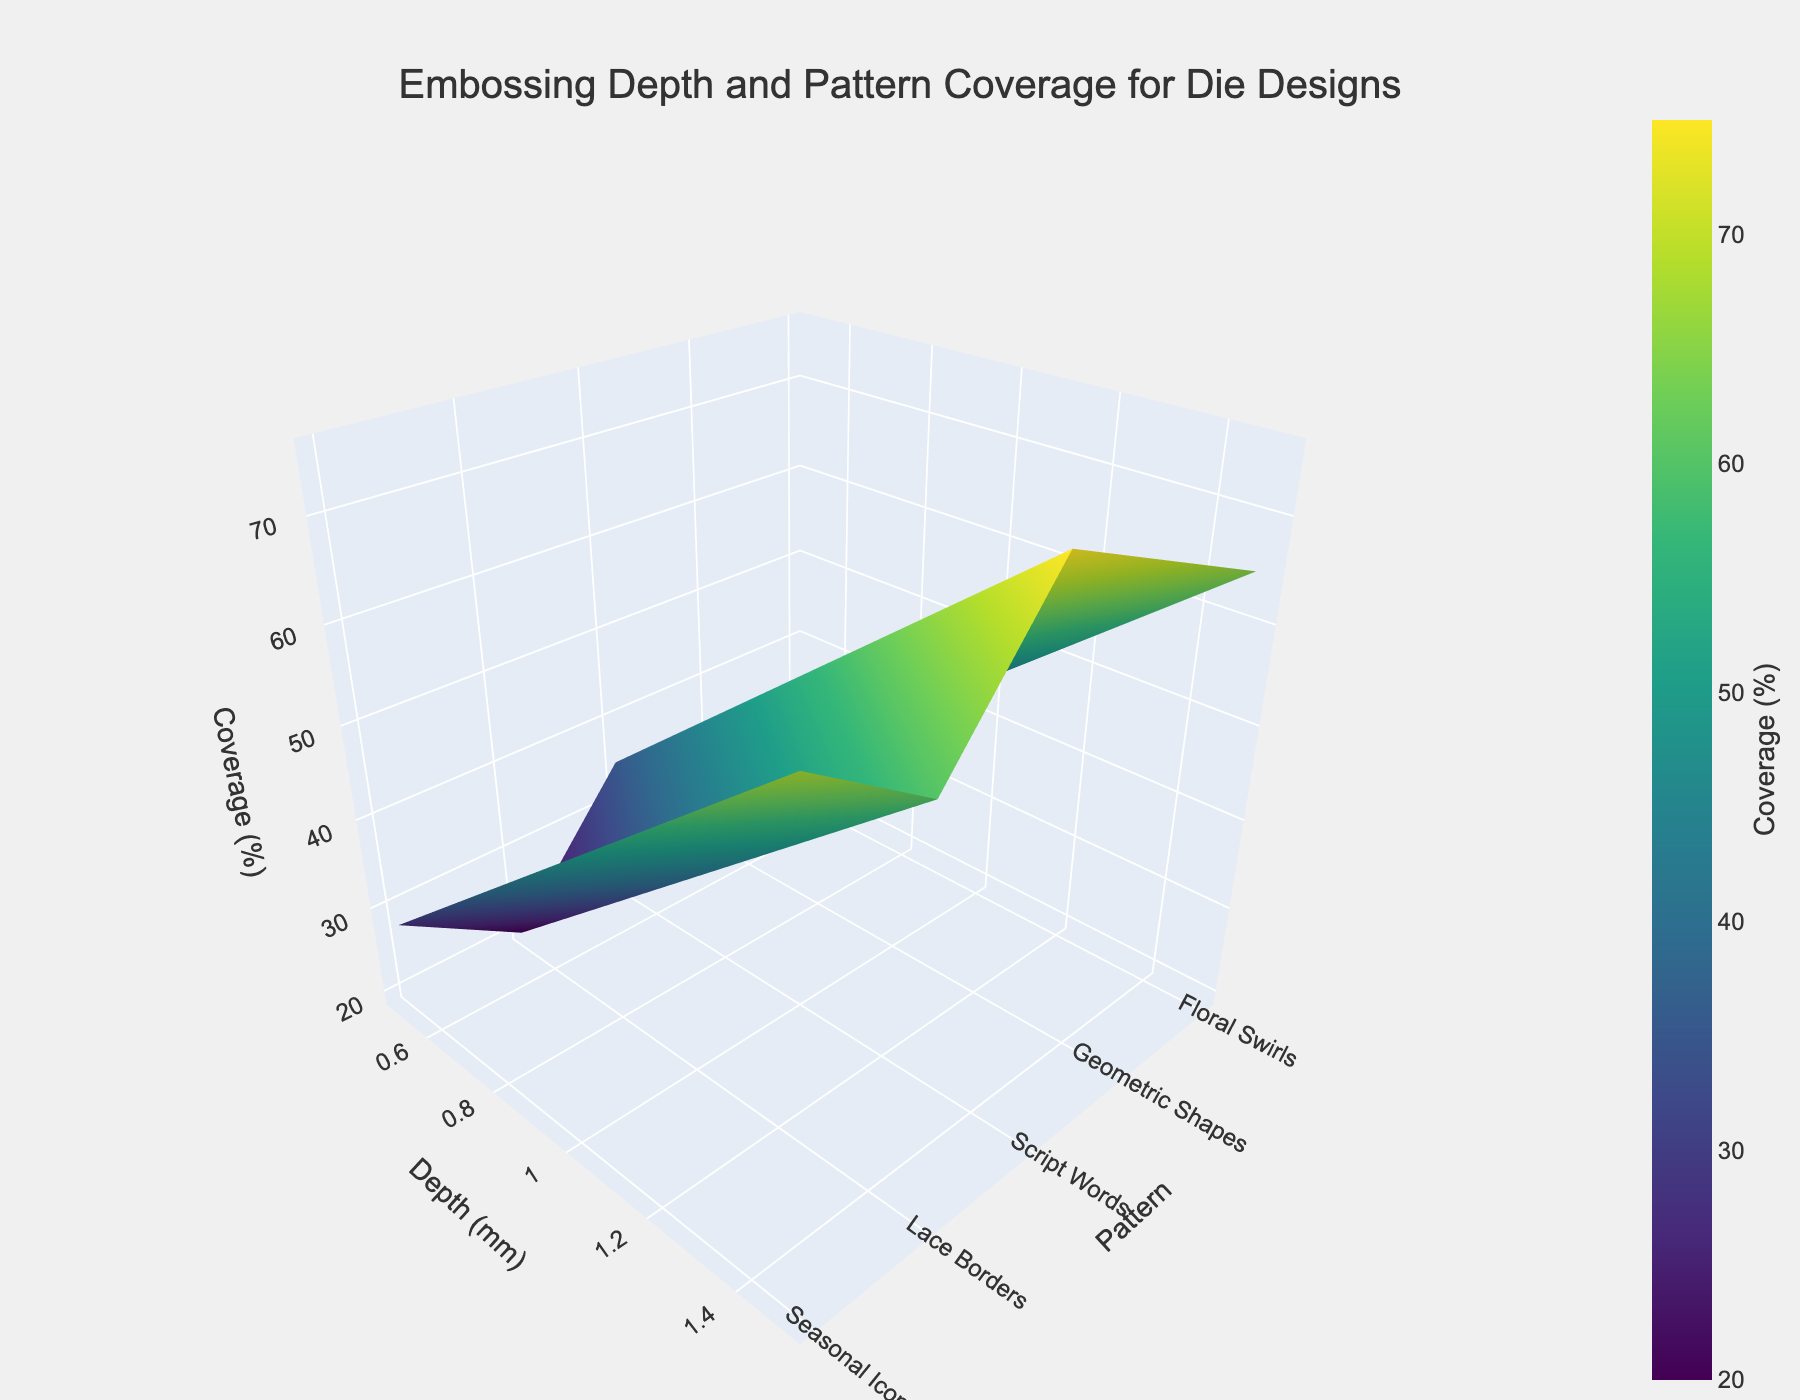What is the title of the figure? The title of the figure can be found at the top center of the plot. It serves to briefly describe the content or purpose of the figure. The title of this specific figure reads "Embossing Depth and Pattern Coverage for Die Designs".
Answer: Embossing Depth and Pattern Coverage for Die Designs Which pattern has the lowest coverage at a depth of 0.5 mm? To find the pattern with the lowest coverage at a depth of 0.5 mm, look at the z-axis values corresponding to 0.5 mm on the y-axis. The pattern with the minimum value will be the answer. The smallest coverage at 0.5 mm depth belongs to "Script Words".
Answer: Script Words How does the coverage percentage change for "Geometric Shapes" as the depth increases from 0.5 mm to 1.5 mm? To observe the change, look at the z-axis values for "Geometric Shapes" at depths 0.5 mm, 1.0 mm, and 1.5 mm. The coverage increases as follows: 30% at 0.5 mm, 50% at 1.0 mm, and 70% at 1.5 mm.
Answer: It increases from 30% to 70% Which pattern shows the steepest increase in coverage percentage from 0.5 mm to 1.5 mm? To determine which pattern shows the steepest increase, look at the z-axis values for each pattern at 0.5 mm and 1.5 mm depths, and calculate the difference. "Script Words" increases from 20% to 60% (a difference of 40%), which is the smallest change. "Floral Swirls" and "Seasonal Icons" increase by 40%, "Geometric Shapes" by 40%, and "Lace Borders" by 40%. Since all patterns increase by same percentage, they all have the same steepest increase.
Answer: All patterns show same steep increase by 40% Is there a pattern whose coverage percentage consistently increases by the same amount when the depth increases from 0.5 mm to 1.5 mm? To check for consistent increases, look at the differences in coverage percentages at each depth step for all patterns. For "Floral Swirls", "Geometric Shapes", "Script Words", "Lace Borders" and "Seasonal Icons", the increase is consistent at each step. Each pattern increases by (20), (20), (20), (20), and (20) percentage points, respectively. Thus, all these patterns show a consistent increase.
Answer: All patterns At a depth of 1.0 mm, which pattern has the highest coverage percentage? To find the pattern with the highest coverage at a depth of 1.0 mm, look at the z-axis values corresponding to a depth of 1.0 mm on the y-axis. The pattern with the maximum value is "Lace Borders" with 55% coverage.
Answer: Lace Borders What is the range of coverage percentages for "Seasonal Icons" at all depths? To find the range, look at the minimum and maximum values of the z-axis for "Seasonal Icons" across all depths. The values are 28% at 0.5 mm and 68% at 1.5 mm. The range is 68% - 28% = 40%.
Answer: 40% How do the coverage percentages for "Floral Swirls" and "Lace Borders" compare at a depth of 1.5 mm? To compare, look at the z-axis values for "Floral Swirls" and "Lace Borders" at a depth of 1.5 mm. "Floral Swirls" has a coverage of 65%, while "Lace Borders" has a coverage of 75%. "Lace Borders" has a higher coverage than "Floral Swirls" at this depth.
Answer: Lace Borders is higher with 75% What is the average coverage percentage at a depth of 1.0 mm across all patterns? To find the average, sum up all coverage percentages at 1.0 mm depth and divide by the number of patterns. Adding these: 45% (Floral Swirls) + 50% (Geometric Shapes) + 40% (Script Words) + 55% (Lace Borders) + 48% (Seasonal Icons) = 238%. Dividing by 5 patterns gives 238% / 5 = 47.6%.
Answer: 47.6% 